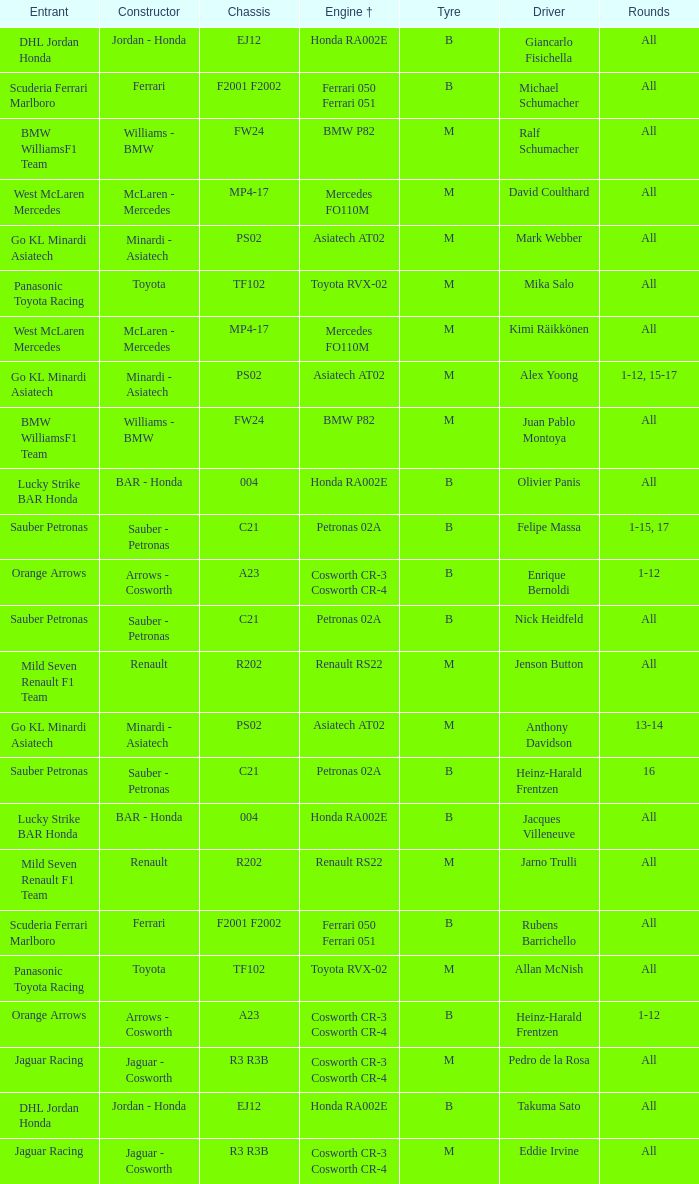What is the chassis when the tyre is b, the engine is ferrari 050 ferrari 051 and the driver is rubens barrichello? F2001 F2002. 